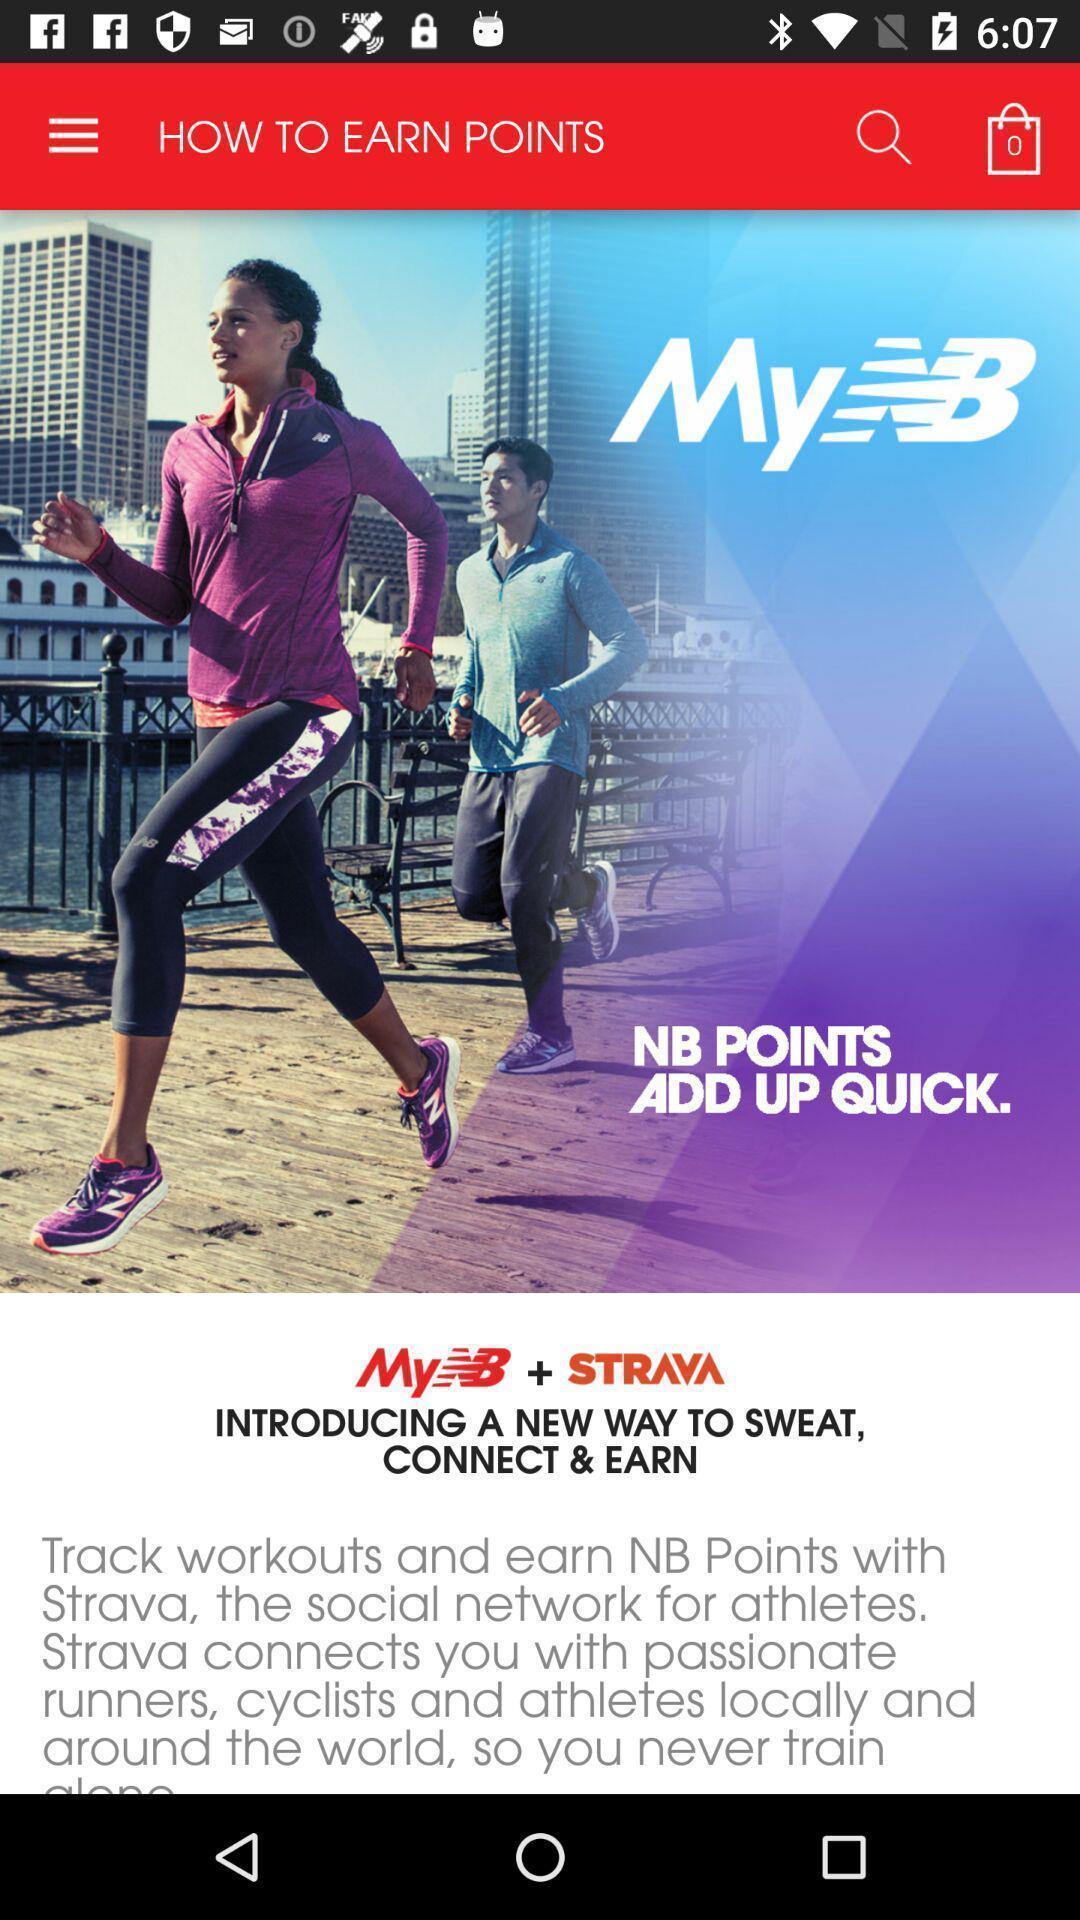Tell me what you see in this picture. Starting page of a fitness app. 